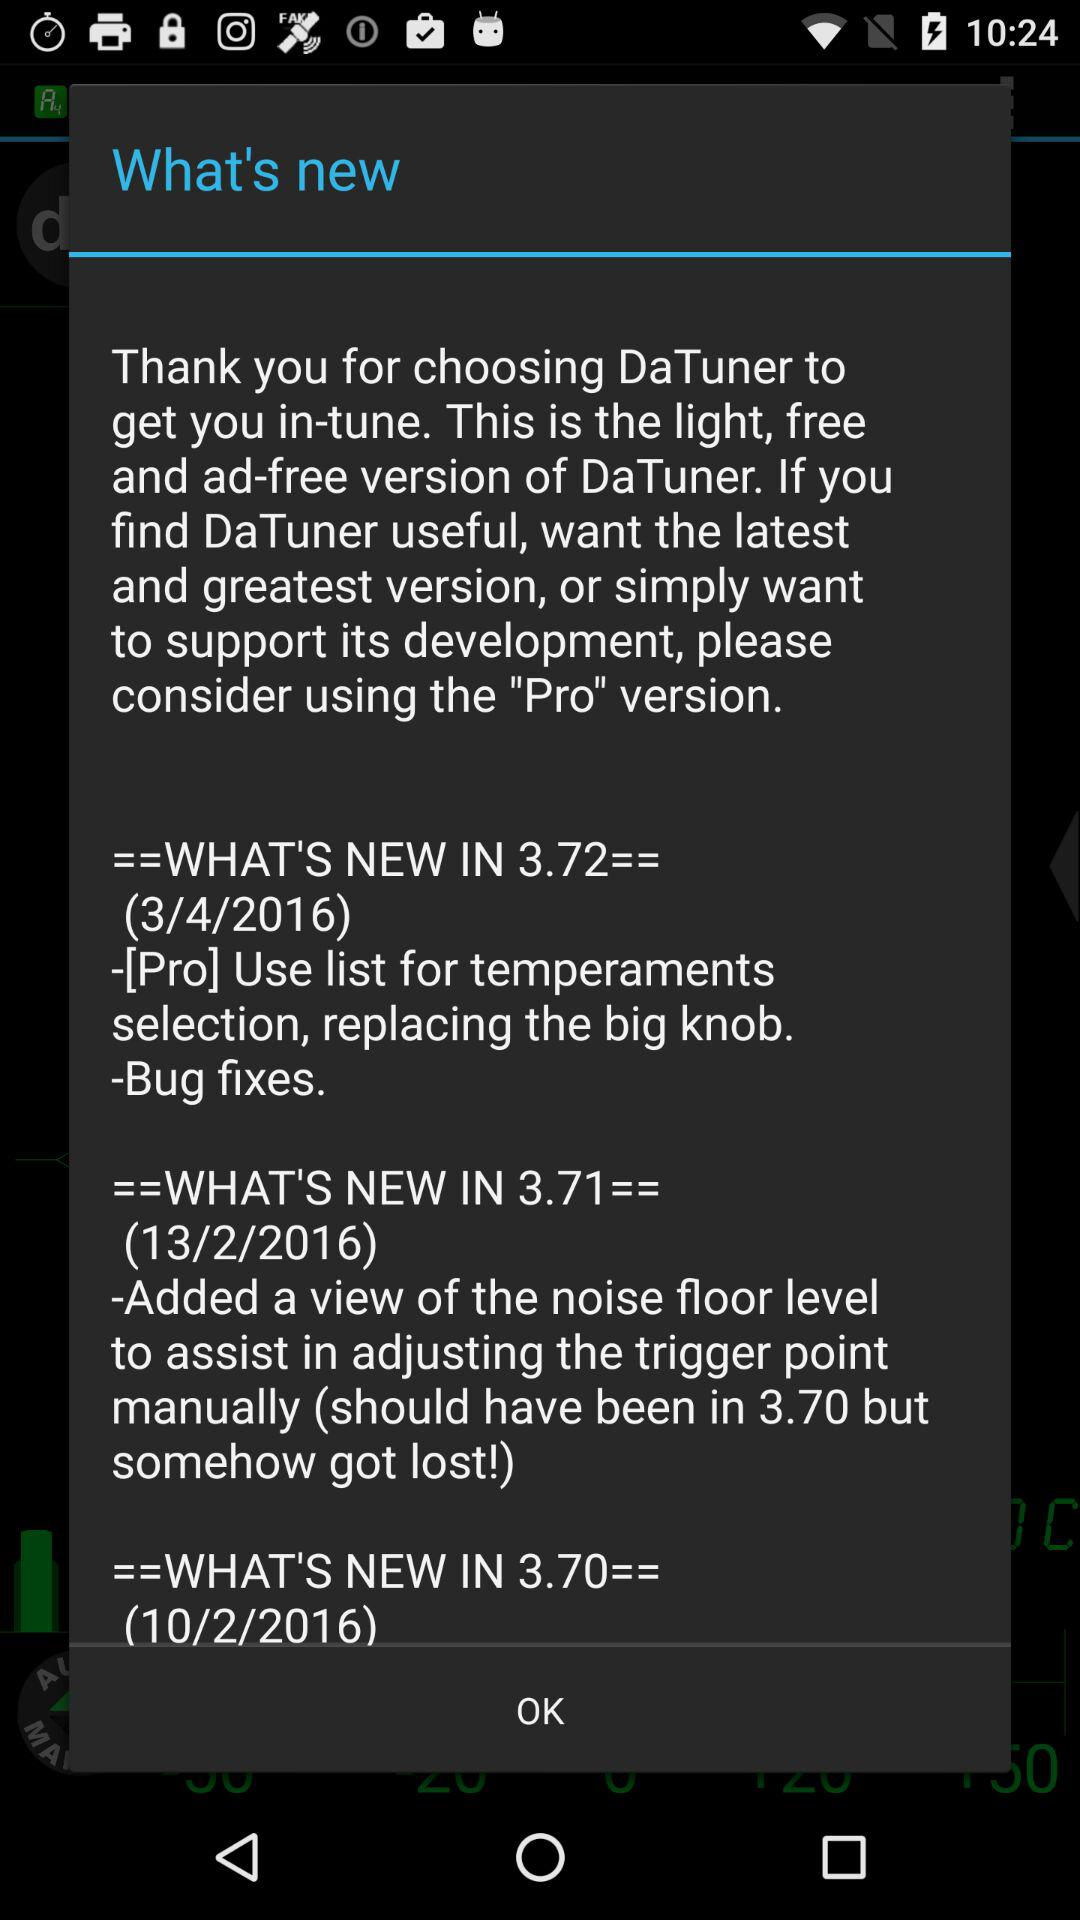How many versions of DaTuner are mentioned in the What's New section?
Answer the question using a single word or phrase. 3 